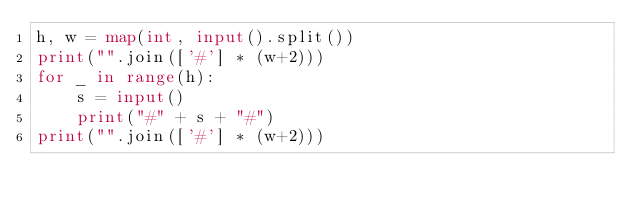<code> <loc_0><loc_0><loc_500><loc_500><_Python_>h, w = map(int, input().split())
print("".join(['#'] * (w+2)))
for _ in range(h):
    s = input()
    print("#" + s + "#")
print("".join(['#'] * (w+2)))</code> 